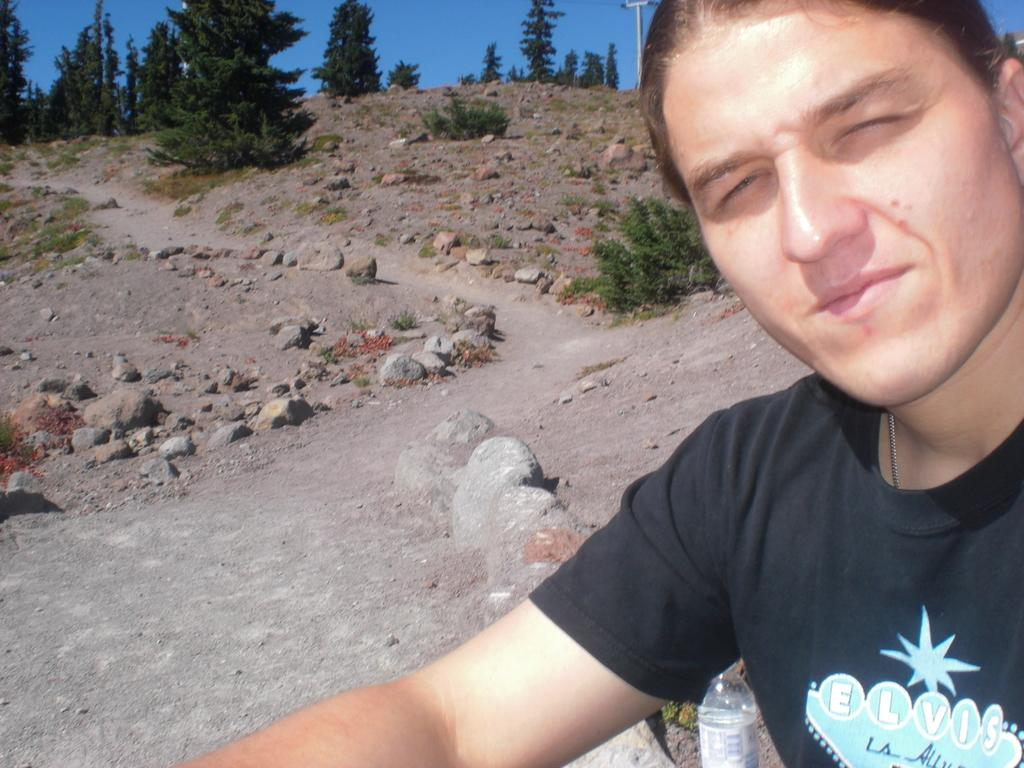What can be seen parked in the image? There are cars parked in the image. What type of barrier is present in the image? There is a fence in the image. What type of vegetation is visible in the image? There are trees in the image. What type of entrance is present in the image? There is a gate in the image. What type of building is visible in the image? There is a stone building in the image. What is visible in the background of the image? The sky is visible in the background of the image. What can be seen in the sky in the image? There are clouds in the sky. Can you tell me how many toes are visible on the cars in the image? Cars do not have toes, so none can be seen in the image. What type of friction is present between the cars and the fence in the image? The image does not provide information about the friction between the cars and the fence. 